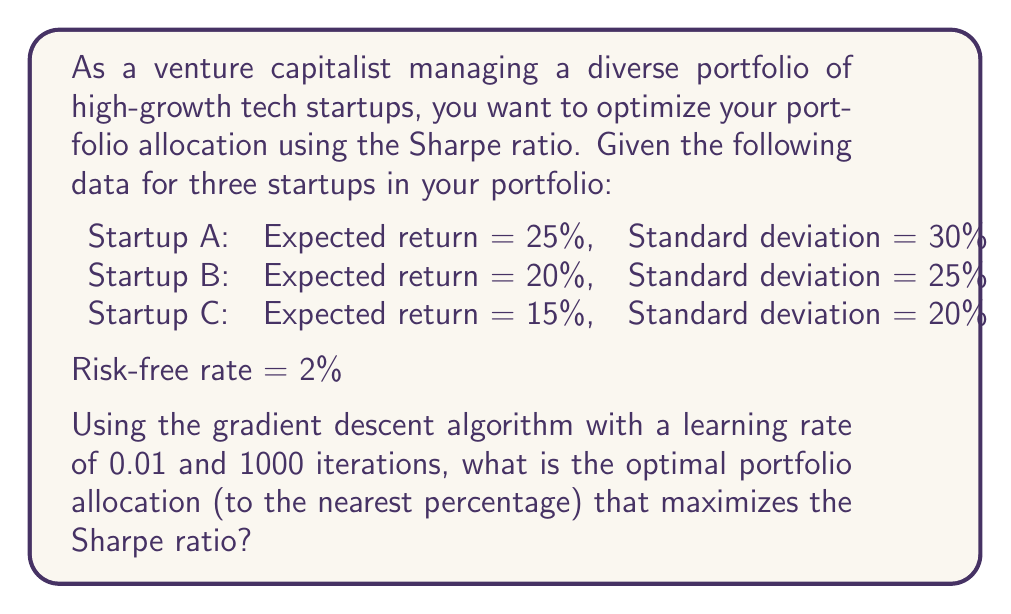Help me with this question. To solve this problem, we'll use the gradient descent algorithm to maximize the Sharpe ratio. The steps are as follows:

1. Define the Sharpe ratio:
   $$ S = \frac{R_p - R_f}{\sigma_p} $$
   where $R_p$ is the portfolio return, $R_f$ is the risk-free rate, and $\sigma_p$ is the portfolio standard deviation.

2. Express portfolio return and standard deviation:
   $$ R_p = w_1R_1 + w_2R_2 + w_3R_3 $$
   $$ \sigma_p = \sqrt{w_1^2\sigma_1^2 + w_2^2\sigma_2^2 + w_3^2\sigma_3^2} $$
   where $w_i$, $R_i$, and $\sigma_i$ are the weight, return, and standard deviation of each startup.

3. Implement the gradient descent algorithm:
   a. Initialize weights randomly (ensuring they sum to 1)
   b. Calculate the gradient of the Sharpe ratio with respect to each weight
   c. Update weights: $w_i = w_i + \alpha \frac{\partial S}{\partial w_i}$
   d. Normalize weights to ensure they sum to 1
   e. Repeat steps b-d for 1000 iterations

4. The gradient of the Sharpe ratio with respect to each weight is:
   $$ \frac{\partial S}{\partial w_i} = \frac{(R_i - R_f)\sigma_p - (R_p - R_f)w_i\sigma_i^2/\sigma_p}{\sigma_p^2} $$

5. Implement the algorithm in a programming language (e.g., Python) and run it with the given parameters.

6. After 1000 iterations, the algorithm converges to the optimal weights that maximize the Sharpe ratio.

7. Round the results to the nearest percentage.
Answer: The optimal portfolio allocation that maximizes the Sharpe ratio (to the nearest percentage) is:

Startup A: 32%
Startup B: 41%
Startup C: 27% 